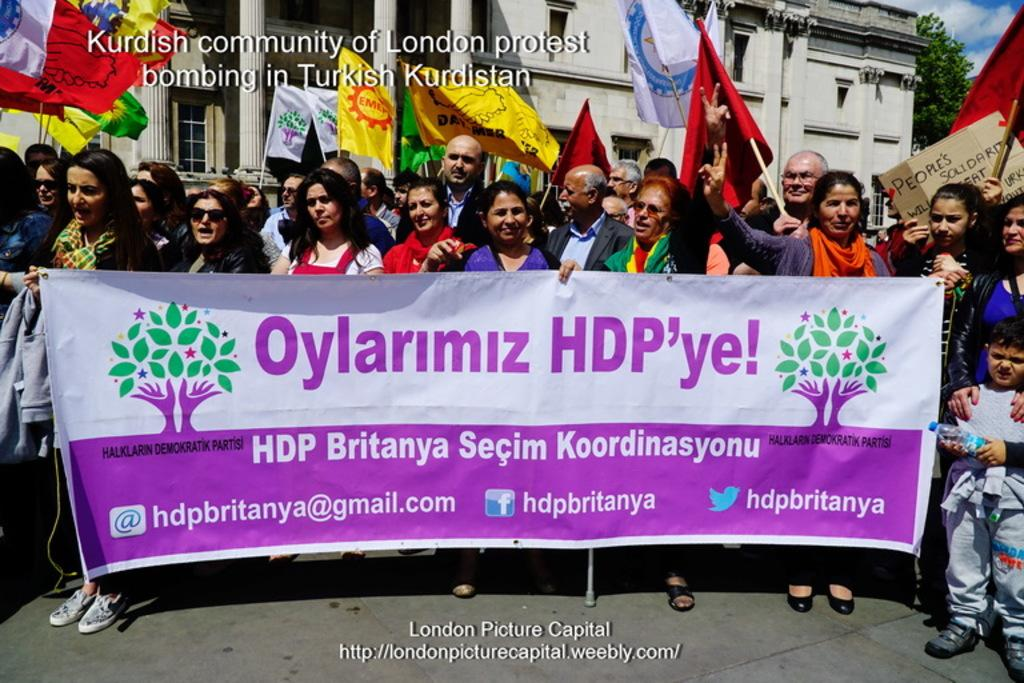What is happening in the image involving a group of people? There is a group of people in the image, and they are holding a banner. What else can be seen in the image related to the group of people? There are flags in the image as well. Where are the group of people and the flags located in the image? They are in front of a building. What type of sheet is being used by the judge in the image? There is no judge or sheet present in the image. Can you describe the monkey's interaction with the banner in the image? There is no monkey present in the image; it only features a group of people holding a banner. 